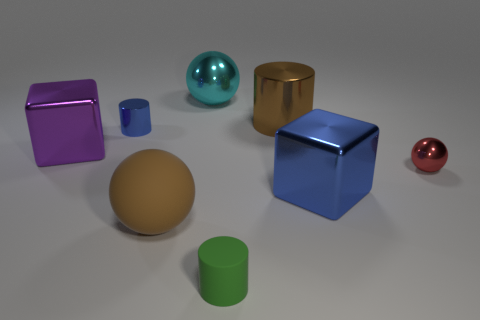Subtract all tiny cylinders. How many cylinders are left? 1 Add 1 large green shiny cylinders. How many objects exist? 9 Subtract all red spheres. How many spheres are left? 2 Subtract 0 cyan cubes. How many objects are left? 8 Subtract all spheres. How many objects are left? 5 Subtract all red cylinders. Subtract all blue spheres. How many cylinders are left? 3 Subtract all green matte objects. Subtract all matte cylinders. How many objects are left? 6 Add 6 large purple blocks. How many large purple blocks are left? 7 Add 6 big red rubber balls. How many big red rubber balls exist? 6 